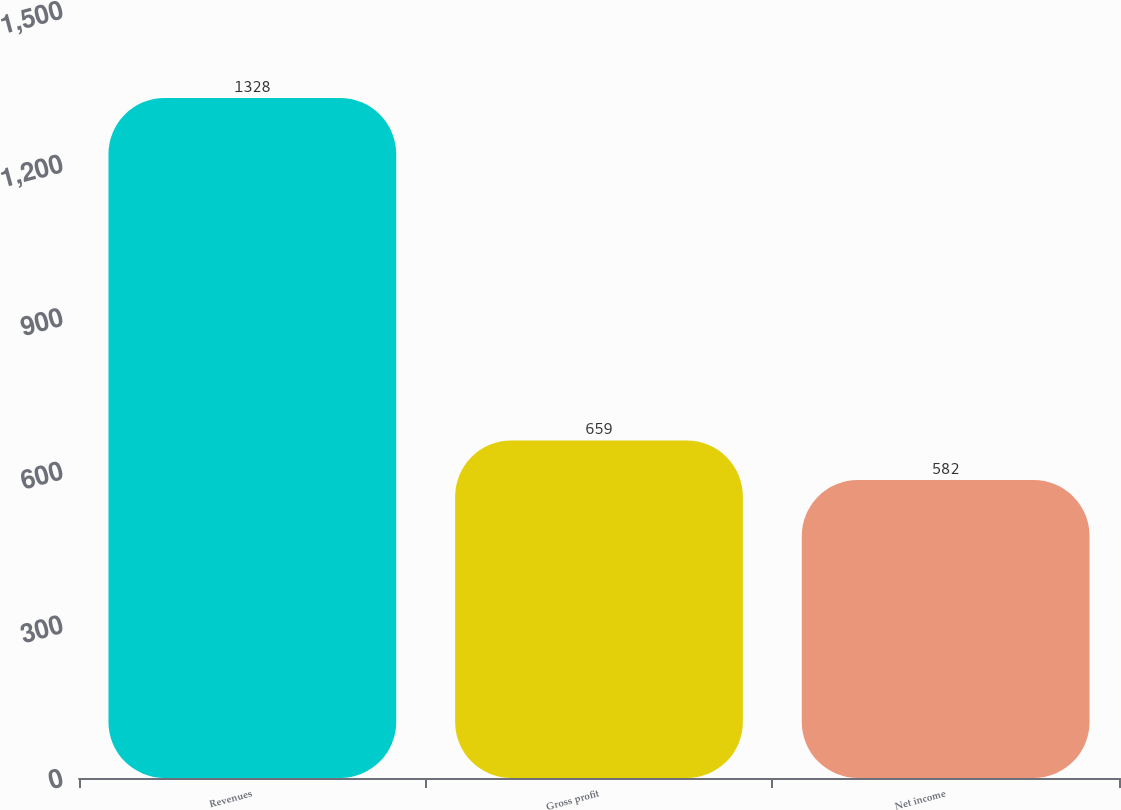Convert chart. <chart><loc_0><loc_0><loc_500><loc_500><bar_chart><fcel>Revenues<fcel>Gross profit<fcel>Net income<nl><fcel>1328<fcel>659<fcel>582<nl></chart> 